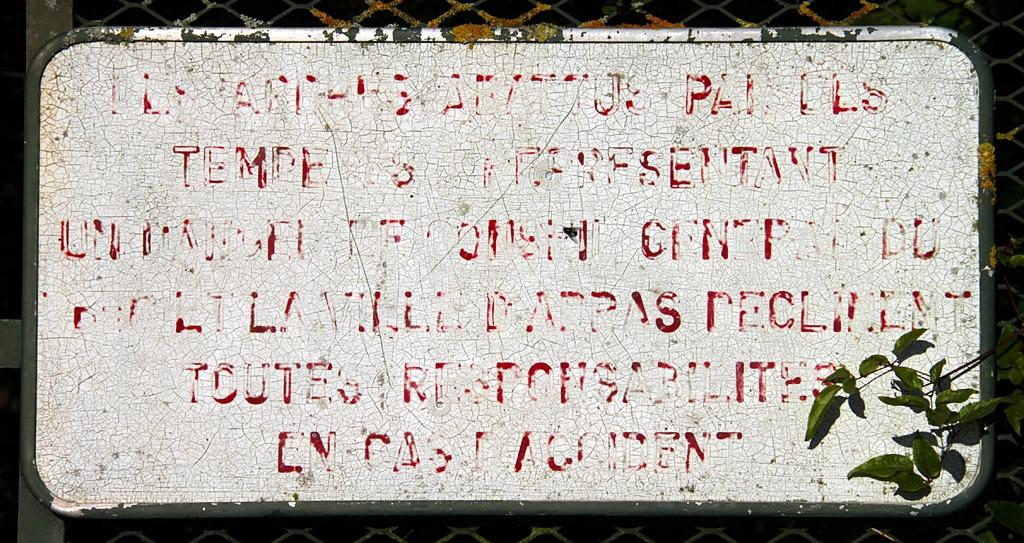What is the main object in the image? There is a board in the image. What is written or depicted on the board? There is text on the board. Are there any other elements visible in the image besides the board? Yes, there are leaves of a plant visible at the right bottom of the image. How many snakes are slithering on the board in the image? There are no snakes present in the image. What type of yarn is used to create the text on the board? The text on the board is not created with yarn; it is likely printed or written. 